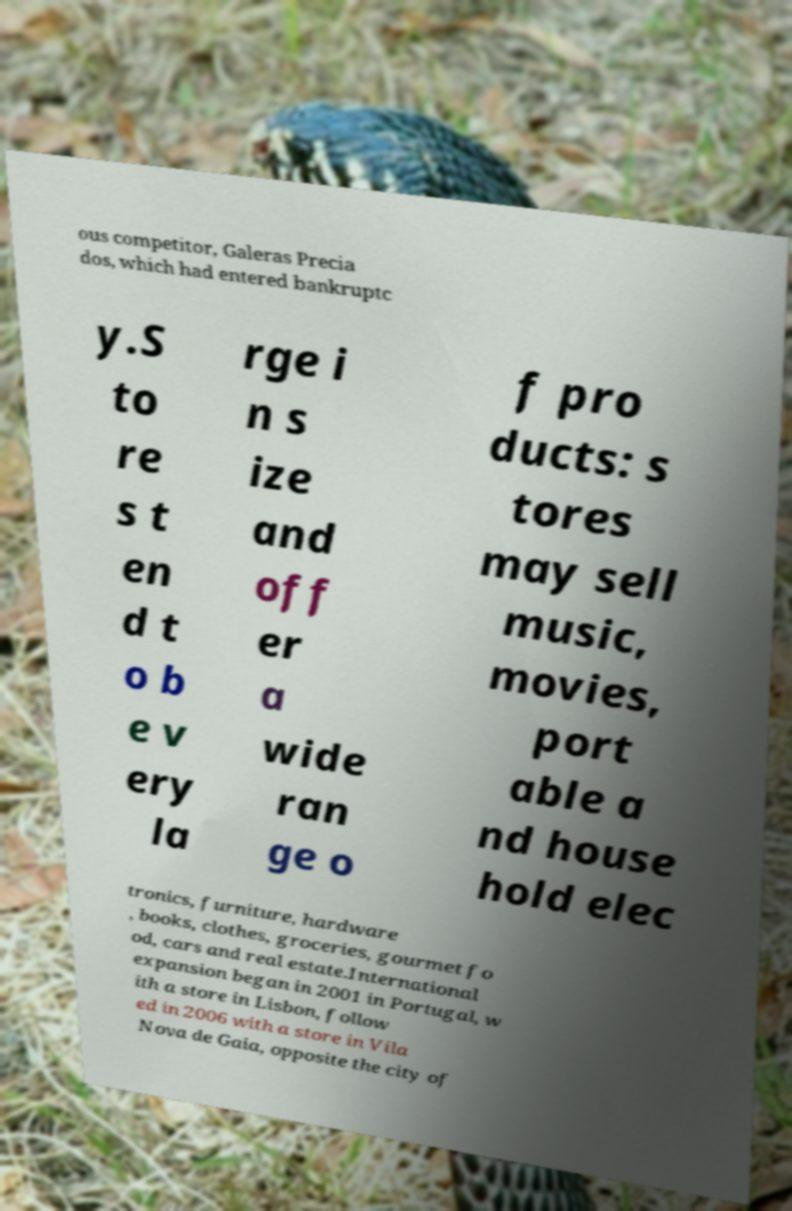Could you assist in decoding the text presented in this image and type it out clearly? ous competitor, Galeras Precia dos, which had entered bankruptc y.S to re s t en d t o b e v ery la rge i n s ize and off er a wide ran ge o f pro ducts: s tores may sell music, movies, port able a nd house hold elec tronics, furniture, hardware , books, clothes, groceries, gourmet fo od, cars and real estate.International expansion began in 2001 in Portugal, w ith a store in Lisbon, follow ed in 2006 with a store in Vila Nova de Gaia, opposite the city of 